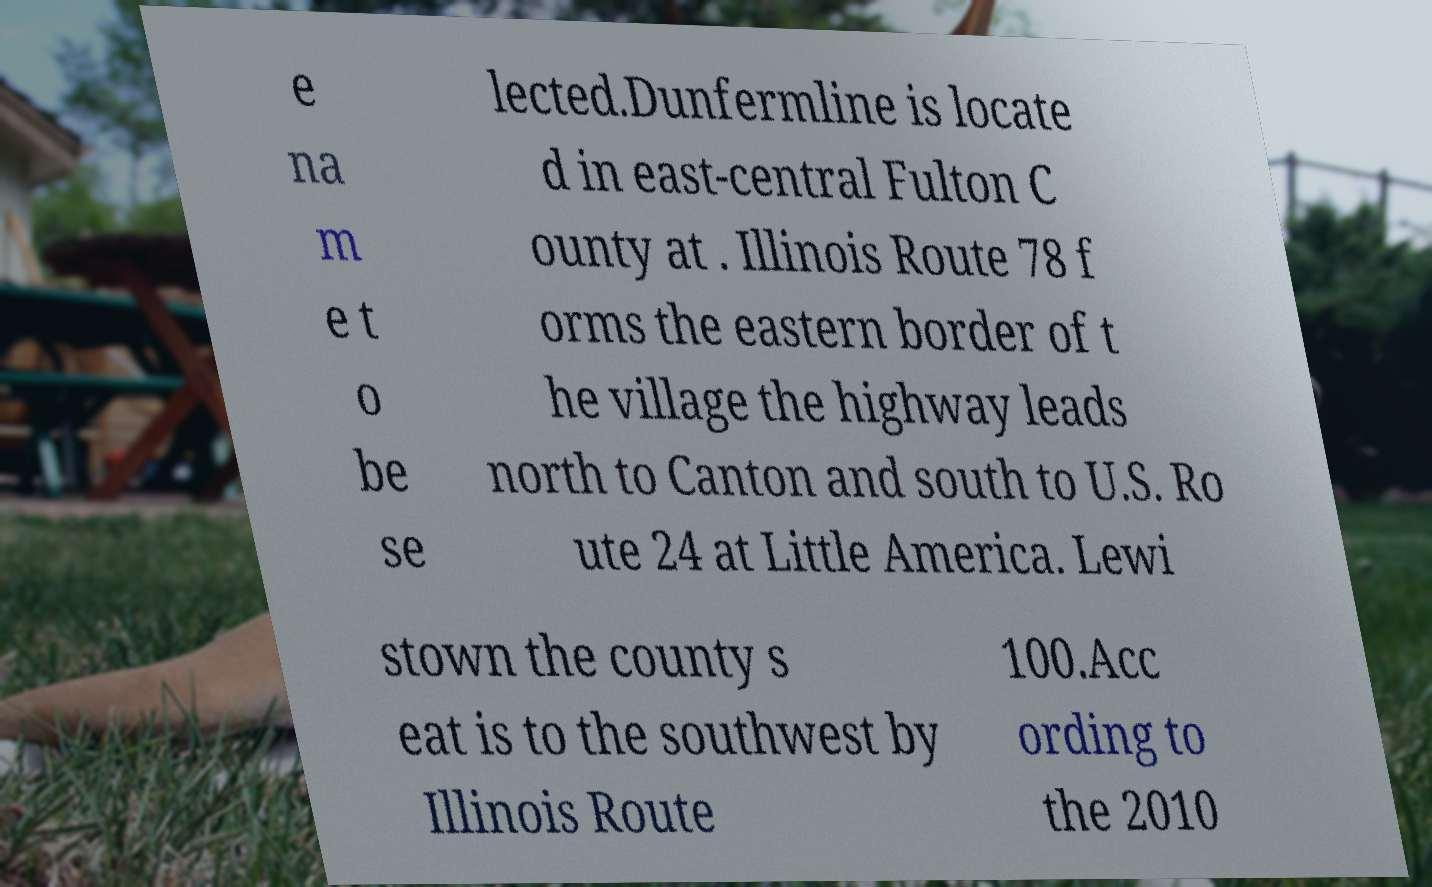Please identify and transcribe the text found in this image. e na m e t o be se lected.Dunfermline is locate d in east-central Fulton C ounty at . Illinois Route 78 f orms the eastern border of t he village the highway leads north to Canton and south to U.S. Ro ute 24 at Little America. Lewi stown the county s eat is to the southwest by Illinois Route 100.Acc ording to the 2010 